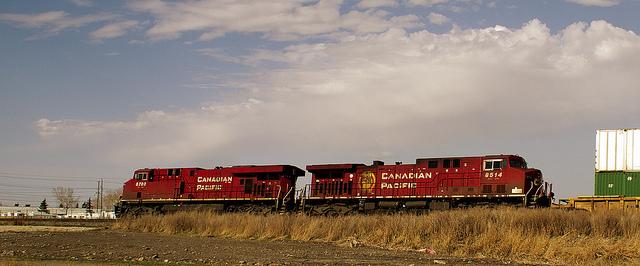What color is the main car?
Short answer required. Red. Are there clouds in the sky?
Give a very brief answer. Yes. What kind of weather is this?
Concise answer only. Cloudy. 